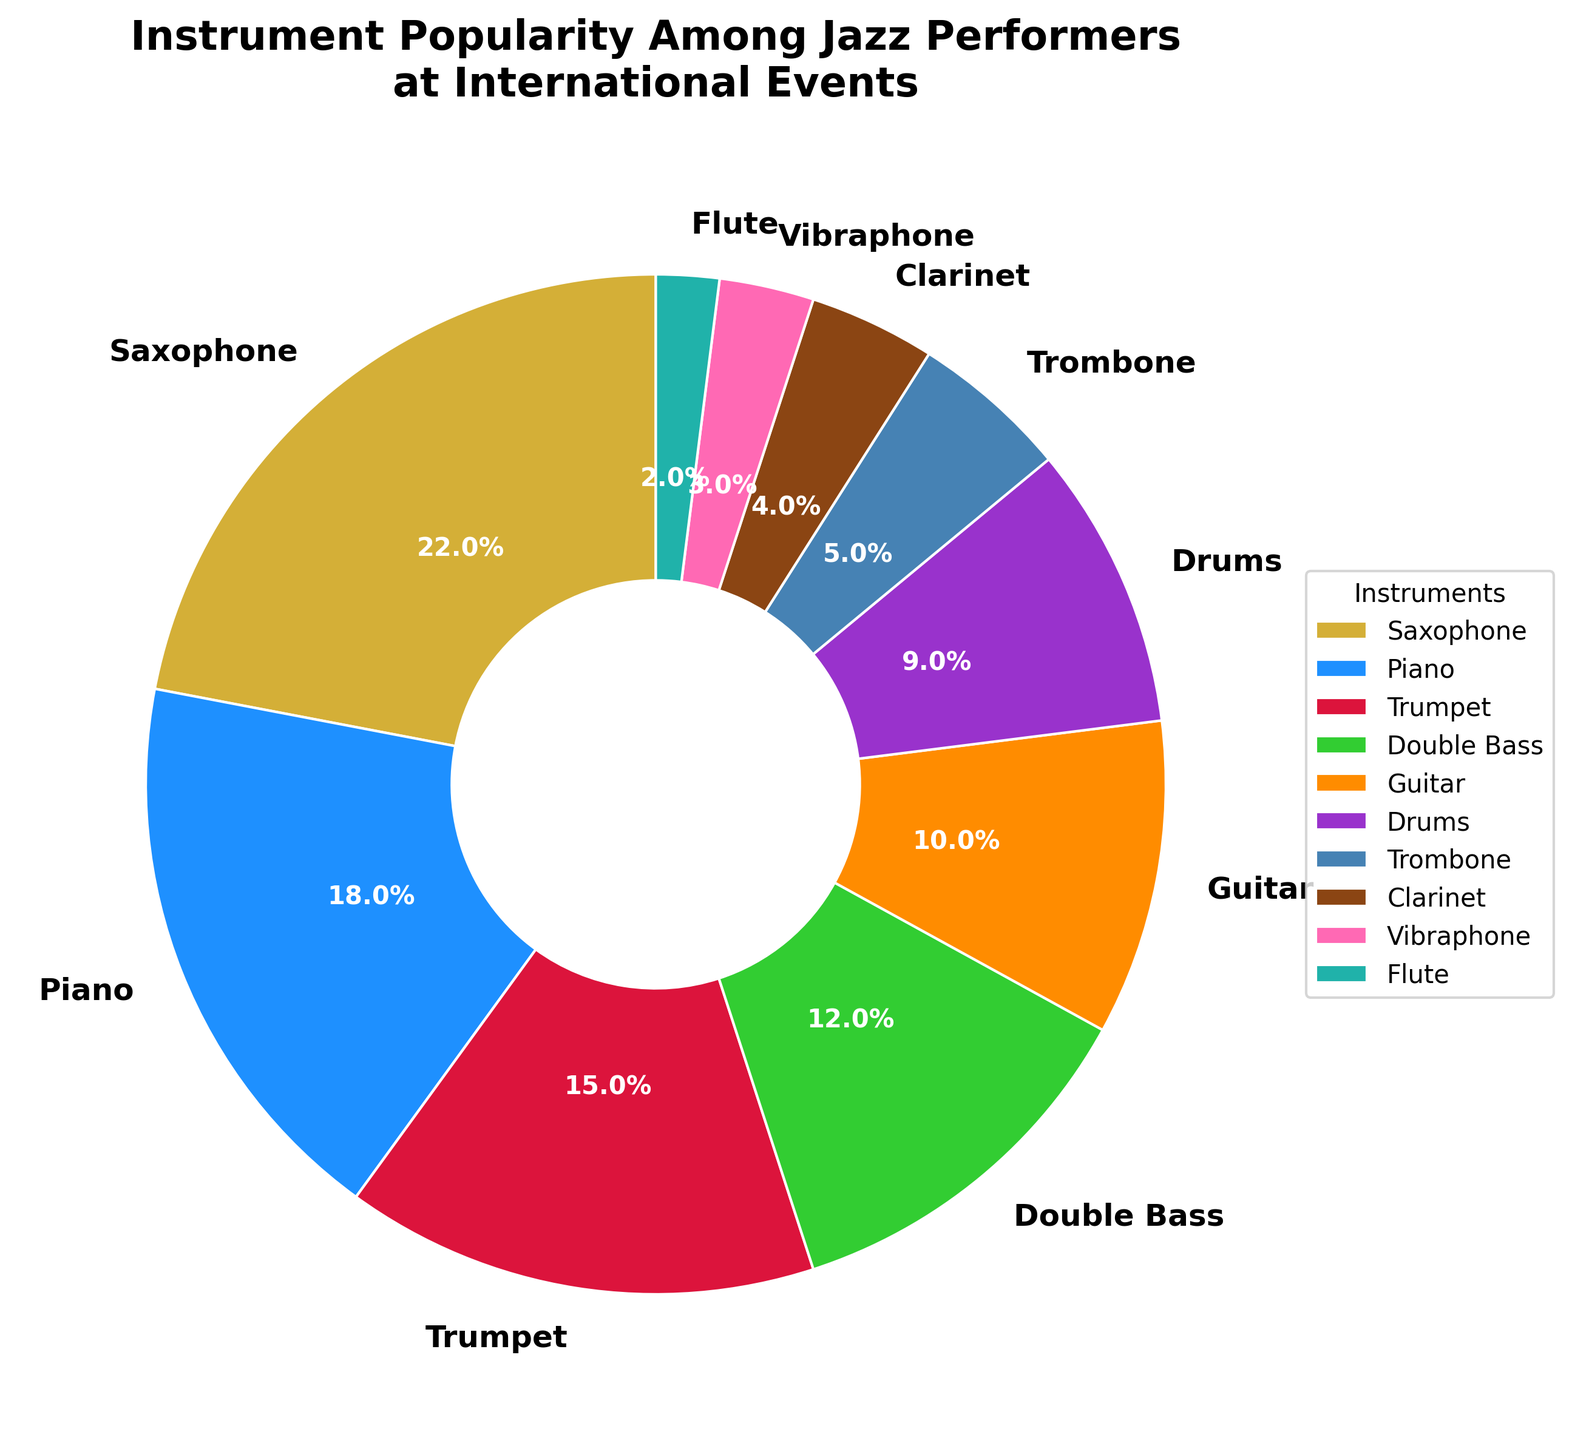What instrument has the highest popularity among jazz performers? The Saxophone section has the largest wedge in the pie chart, indicating it has the highest percentage.
Answer: Saxophone Which two instruments combined make up over one-third of the performers? The percentages of Saxophone (22%) and Piano (18%) add up to 40%. Since 40% is more than one-third (33.33%), these two add up to over one-third of the performers.
Answer: Saxophone and Piano How much more popular is the Saxophone compared to the Flute? The Saxophone has a 22% share, and the Flute has a 2% share. The difference is calculated as 22% - 2% = 20%.
Answer: 20% List the instruments that occupy less than 10% of the chart each. The instruments with less than 10% in the chart are Drums (9%), Trombone (5%), Clarinet (4%), Vibraphone (3%), and Flute (2%).
Answer: Drums, Trombone, Clarinet, Vibraphone, and Flute What is the total percentage occupied by the Guitar and Drums combined? The Guitar occupies 10% and Drums occupy 9%. Adding these together: 10% + 9% = 19%.
Answer: 19% Compare the popularity of the Piano to the Double Bass. The Piano has a percentage of 18%, while the Double Bass has a percentage of 12%. Since 18% is greater than 12%, the Piano is more popular.
Answer: Piano What is the average percentage of the four least popular instruments? The four least popular instruments are Flute (2%), Vibraphone (3%), Clarinet (4%), and Trombone (5%). The sum of these percentages is 2% + 3% + 4% + 5% = 14%. The average is 14% / 4 = 3.5%.
Answer: 3.5% Which instrument has a popularity close to that of the Guitar? The Drums section has a percentage (9%) that is close to the Guitar (10%).
Answer: Drums Is the Trumpet more popular than the Double Bass? The Trumpet has a percentage of 15%, while the Double Bass has a percentage of 12%. Since 15% is greater than 12%, the Trumpet is more popular.
Answer: Yes What instrument combines with the Vibraphone to form a 5% share? The Vibraphone has a 3% share. To form a total of 5%, we need to add the Flute, which has a 2% share. 3% + 2% = 5%.
Answer: Flute 